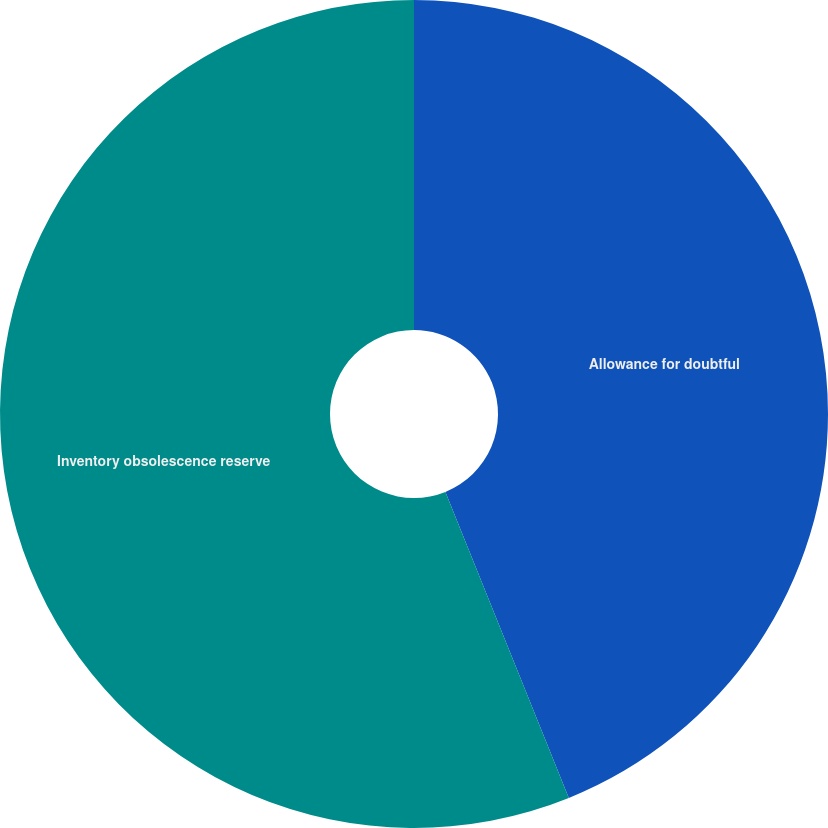Convert chart to OTSL. <chart><loc_0><loc_0><loc_500><loc_500><pie_chart><fcel>Allowance for doubtful<fcel>Inventory obsolescence reserve<nl><fcel>43.9%<fcel>56.1%<nl></chart> 